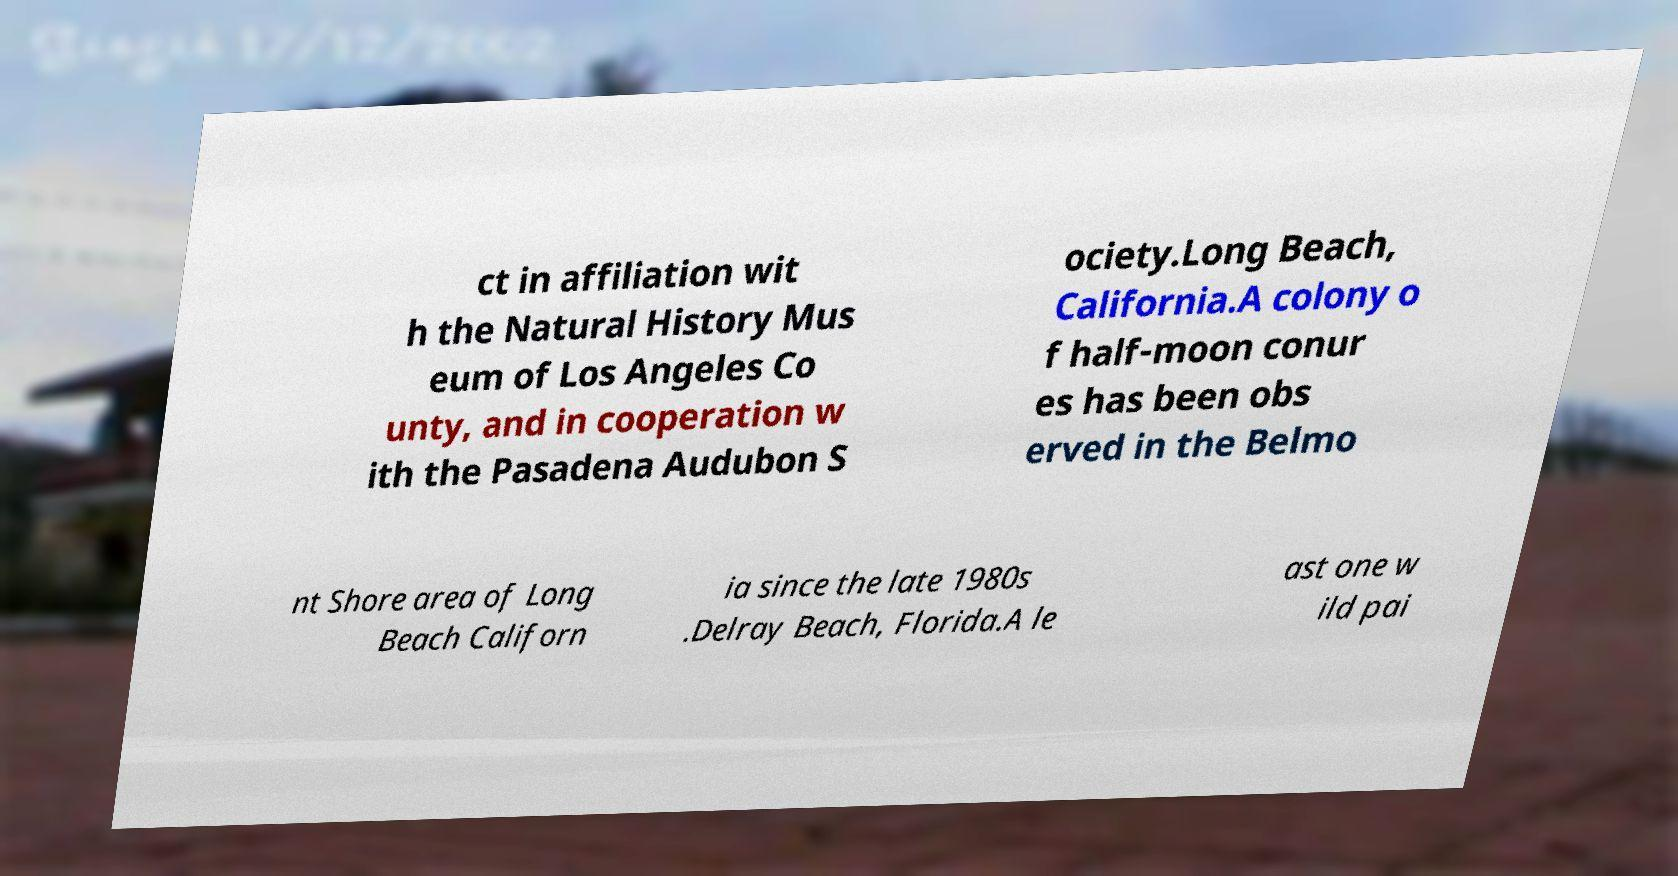Please read and relay the text visible in this image. What does it say? ct in affiliation wit h the Natural History Mus eum of Los Angeles Co unty, and in cooperation w ith the Pasadena Audubon S ociety.Long Beach, California.A colony o f half-moon conur es has been obs erved in the Belmo nt Shore area of Long Beach Californ ia since the late 1980s .Delray Beach, Florida.A le ast one w ild pai 